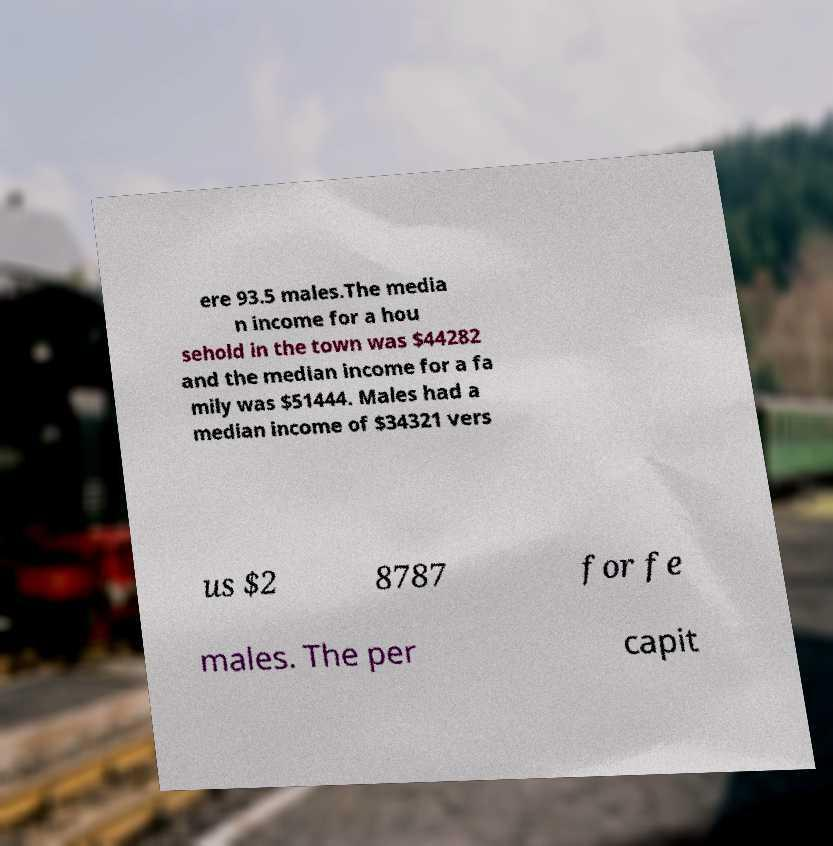Can you accurately transcribe the text from the provided image for me? ere 93.5 males.The media n income for a hou sehold in the town was $44282 and the median income for a fa mily was $51444. Males had a median income of $34321 vers us $2 8787 for fe males. The per capit 